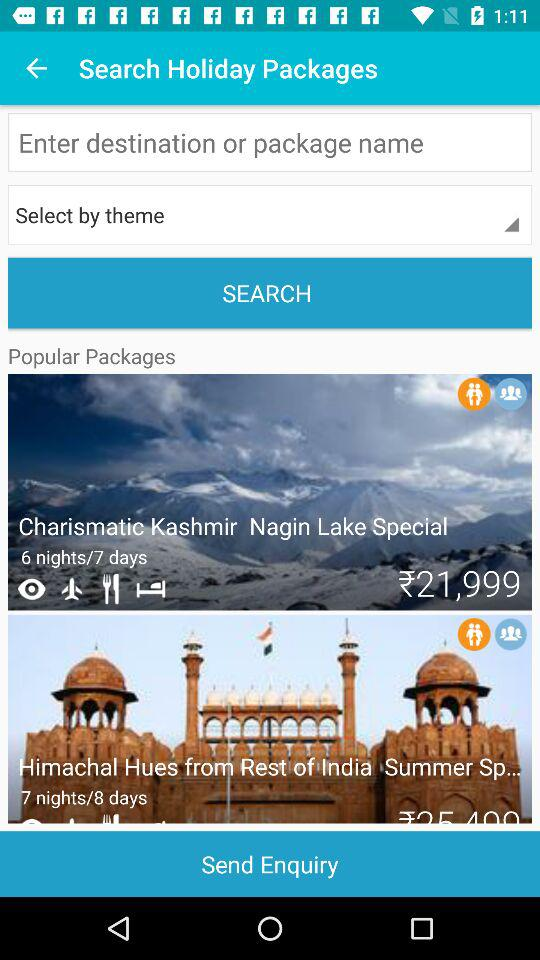What would be the best time to visit the destinations offered in the 'Himachal Hues from Rest of India Summer Special' package? The 'Himachal Hues' package is listed as a Summer Special, which suggests that the ideal time to visit would be from March to June when the weather is most pleasant. During these months, you can enjoy the lush greenery, floral blooms, and comfortable temperatures before the monsoon season begins. 